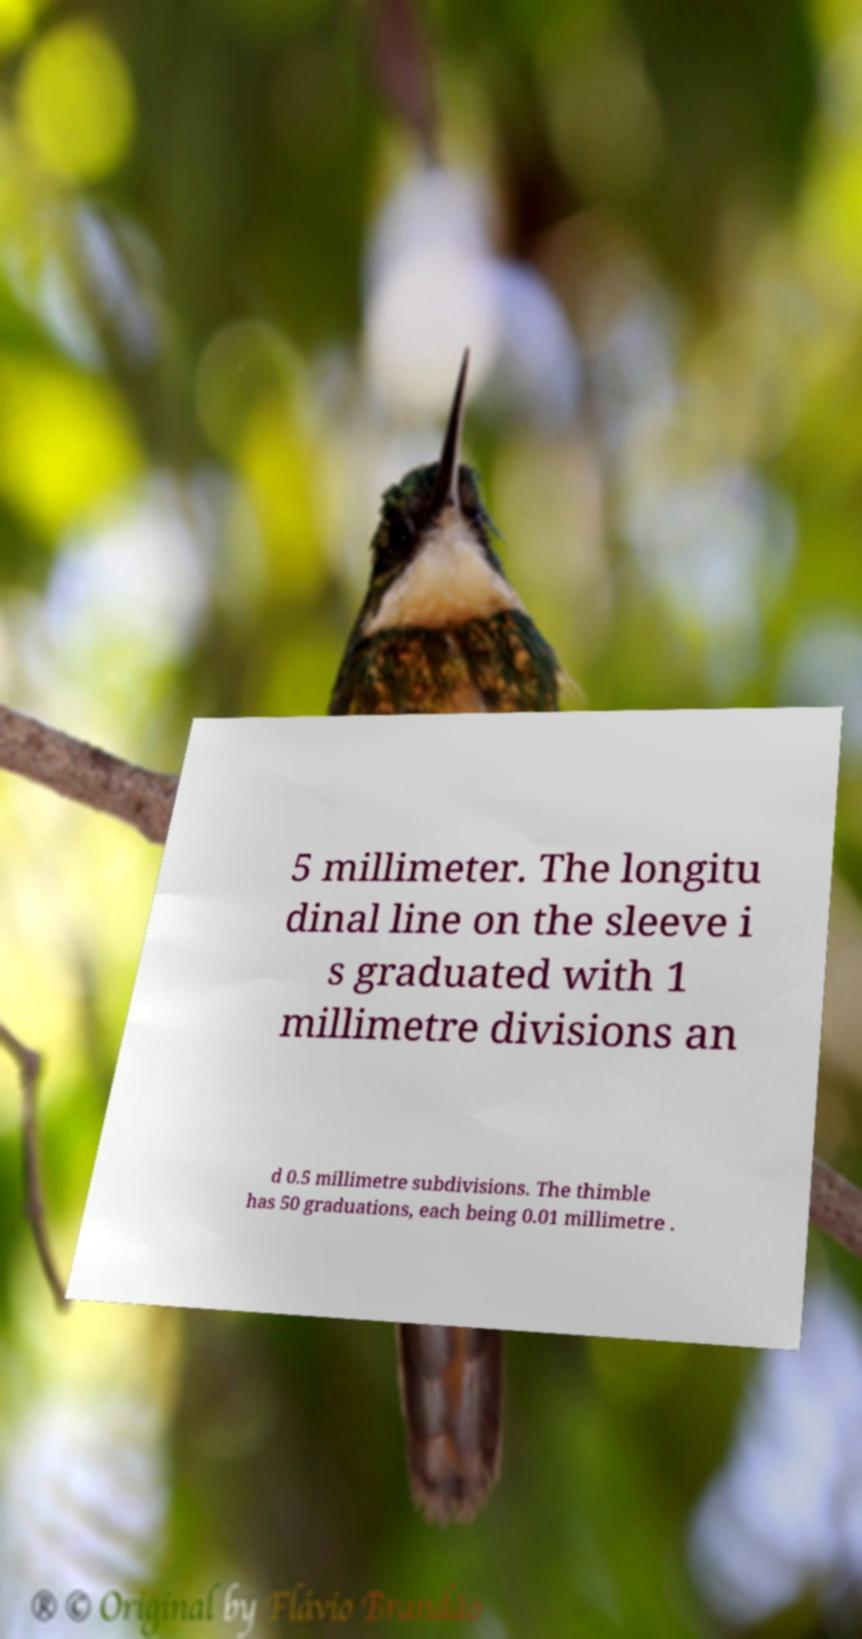Please read and relay the text visible in this image. What does it say? 5 millimeter. The longitu dinal line on the sleeve i s graduated with 1 millimetre divisions an d 0.5 millimetre subdivisions. The thimble has 50 graduations, each being 0.01 millimetre . 